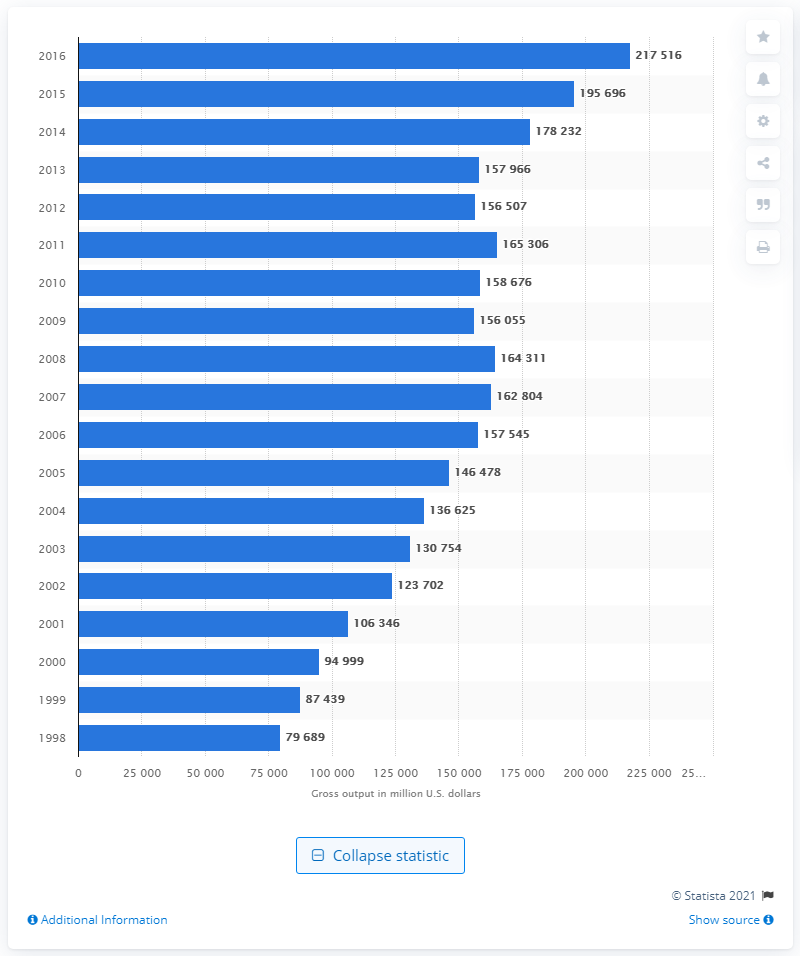Highlight a few significant elements in this photo. In 1998, the gross output of pharmaceutical preparation manufacturing was 79,689. In 2016, the gross output of pharmaceutical preparation manufacturing was 217,516. 